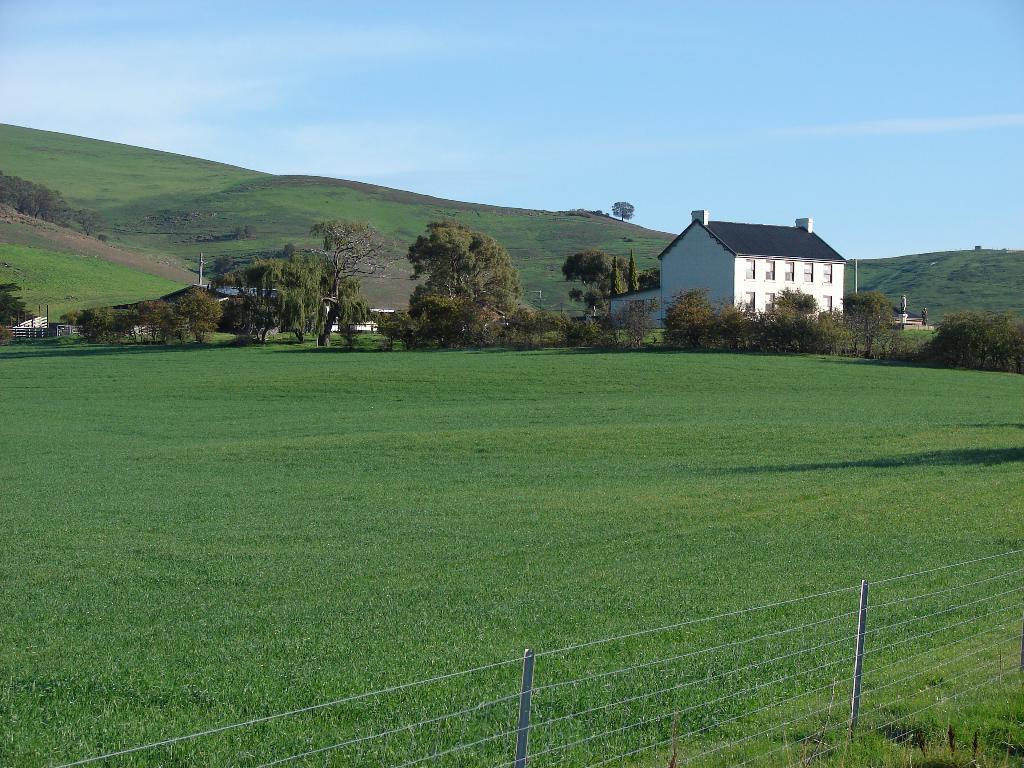Describe this image in one or two sentences. This image is clicked outside. There are trees in the middle. There is a building in the middle. There is sky at the top. There is grass at the bottom. 